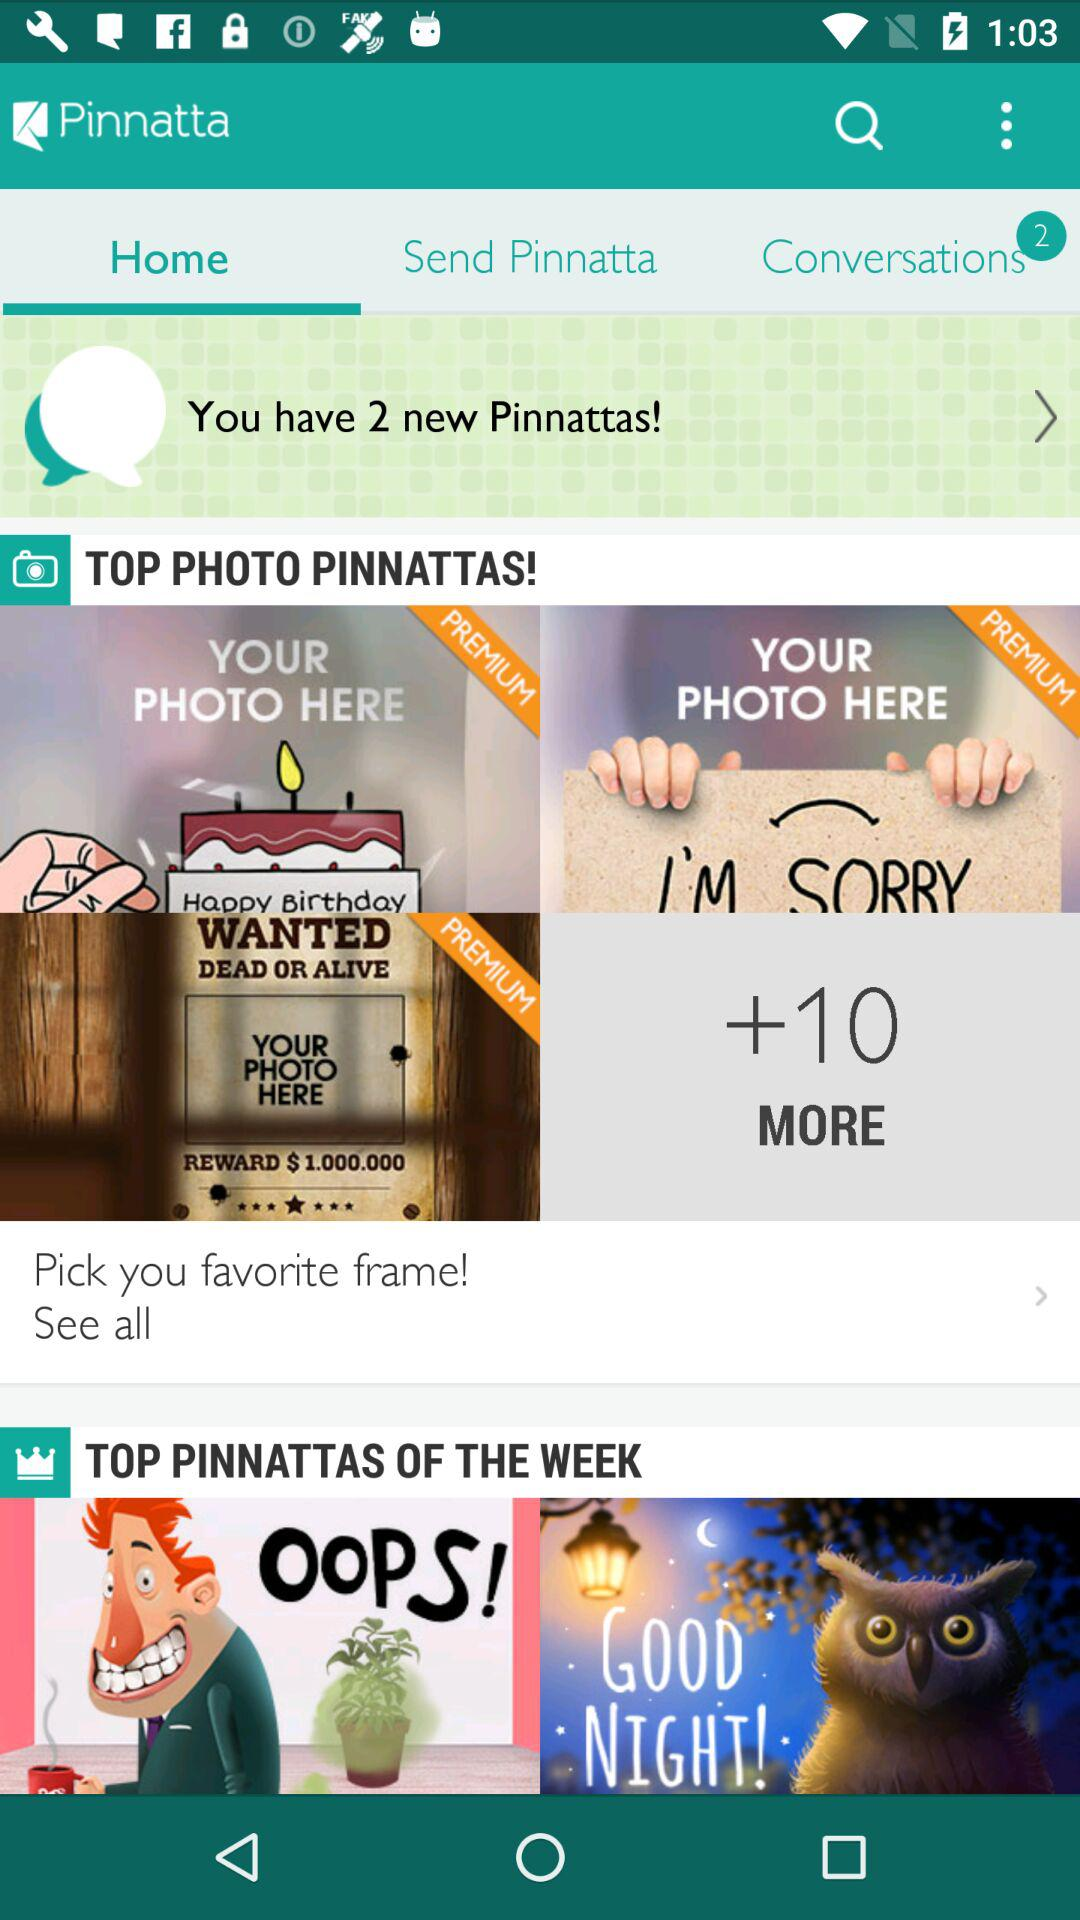How many items are in the top photo pinnattas section?
Answer the question using a single word or phrase. 2 